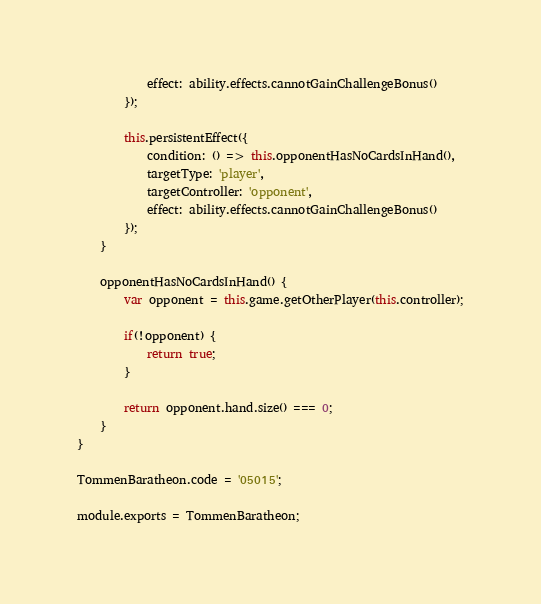<code> <loc_0><loc_0><loc_500><loc_500><_JavaScript_>            effect: ability.effects.cannotGainChallengeBonus()
        });

        this.persistentEffect({
            condition: () => this.opponentHasNoCardsInHand(),
            targetType: 'player',
            targetController: 'opponent',
            effect: ability.effects.cannotGainChallengeBonus()
        });
    }

    opponentHasNoCardsInHand() {
        var opponent = this.game.getOtherPlayer(this.controller);

        if(!opponent) {
            return true;
        }
        
        return opponent.hand.size() === 0;
    }
}

TommenBaratheon.code = '05015';

module.exports = TommenBaratheon;
</code> 